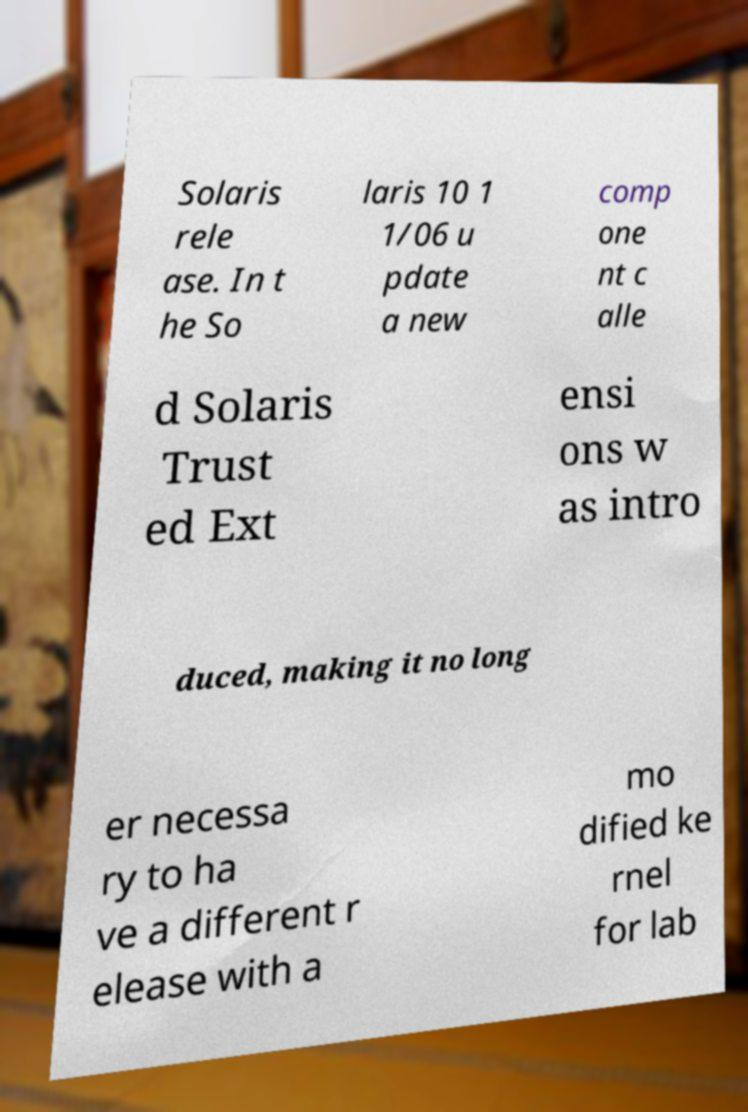Could you assist in decoding the text presented in this image and type it out clearly? Solaris rele ase. In t he So laris 10 1 1/06 u pdate a new comp one nt c alle d Solaris Trust ed Ext ensi ons w as intro duced, making it no long er necessa ry to ha ve a different r elease with a mo dified ke rnel for lab 